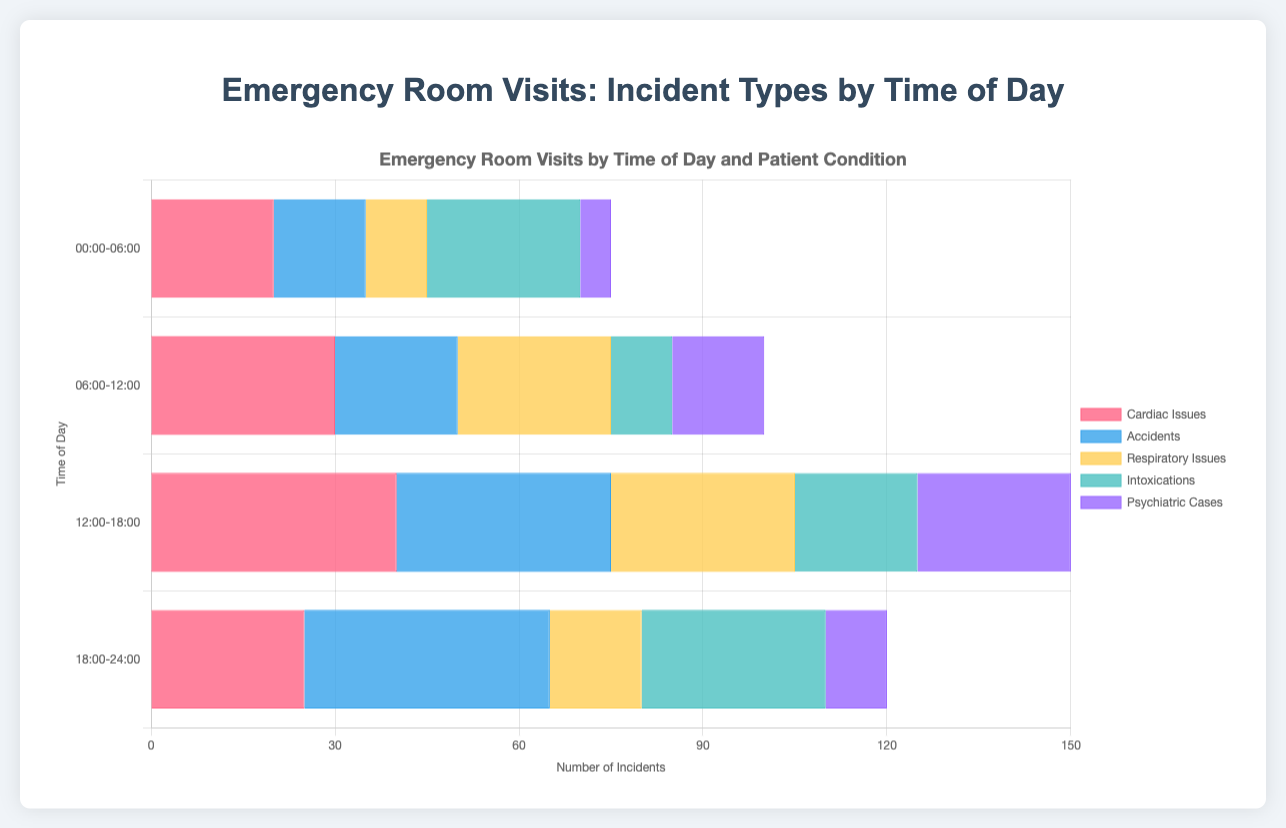How many intoxications are reported throughout the day? First, identify the number of intoxications in each time slot: 25 (00:00-06:00), 10 (06:00-12:00), 20 (12:00-18:00), and 30 (18:00-24:00). Sum these numbers: 25 + 10 + 20 + 30 = 85
Answer: 85 Which condition has the highest number of incidents during 12:00-18:00? Look at the bars for the 12:00-18:00 slot and find the tallest bar or highest value among the condition types: 40 (Cardiac Issues), 35 (Accidents), 30 (Respiratory Issues), 20 (Intoxications), 25 (Psychiatric Cases). The highest is 40 (Cardiac Issues)
Answer: Cardiac Issues Compare the number of cardiac issues reported during the 00:00-06:00 and 18:00-24:00 time slots. Which time slot has fewer incidents? Compare the counts: 20 (00:00-06:00) and 25 (18:00-24:00). The 00:00-06:00 slot has fewer incidents
Answer: 00:00-06:00 What is the sum of respiratory issues reported during the first and last time slots? Add the number of respiratory issues for the 00:00-06:00 (10) and 18:00-24:00 (15) time slots: 10 + 15 = 25
Answer: 25 Which condition has the smallest number of incidents during the 06:00-12:00 time slot? Identify the smallest bar/number in the 06:00-12:00 slot: 30 (Cardiac Issues), 20 (Accidents), 25 (Respiratory Issues), 10 (Intoxications), 15 (Psychiatric Cases). The smallest is 10 (Intoxications)
Answer: Intoxications During which time slot is the number of psychiatric cases highest? Look for the highest value among the psychiatric cases in all time slots: 5 (00:00-06:00), 15 (06:00-12:00), 25 (12:00-18:00), 10 (18:00-24:00). The highest is 25 during 12:00-18:00
Answer: 12:00-18:00 How many more accidents are reported between 12:00-18:00 compared to 00:00-06:00? Subtract the number of accidents reported in the 00:00-06:00 slot (15) from those reported in the 12:00-18:00 slot (35): 35 - 15 = 20
Answer: 20 